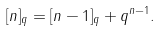<formula> <loc_0><loc_0><loc_500><loc_500>[ n ] _ { q } = [ n - 1 ] _ { q } + q ^ { n - 1 } .</formula> 